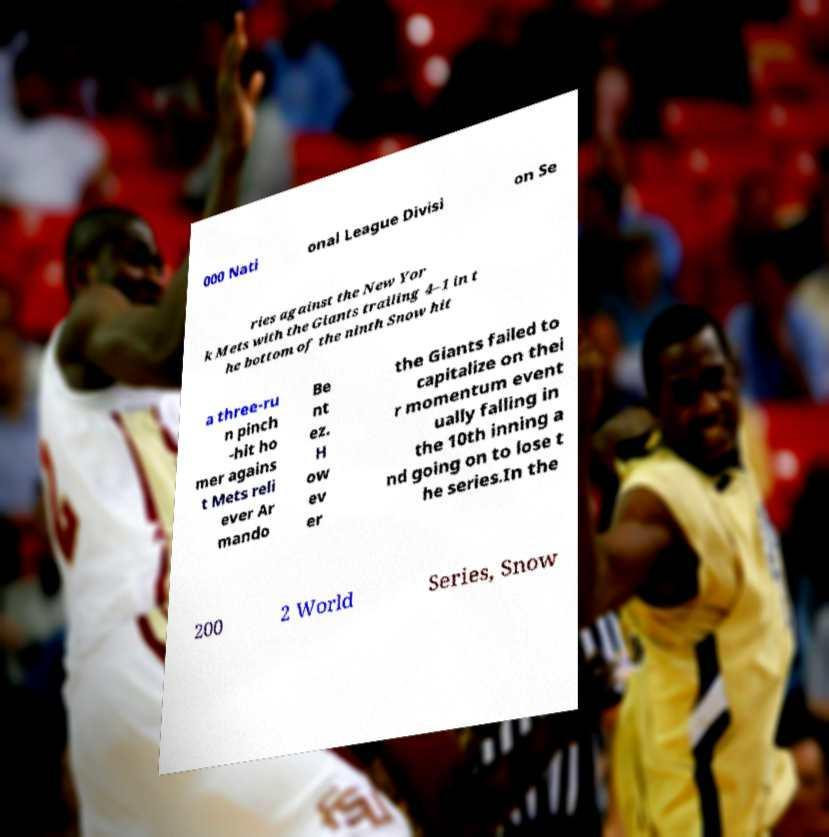There's text embedded in this image that I need extracted. Can you transcribe it verbatim? 000 Nati onal League Divisi on Se ries against the New Yor k Mets with the Giants trailing 4–1 in t he bottom of the ninth Snow hit a three-ru n pinch -hit ho mer agains t Mets reli ever Ar mando Be nt ez. H ow ev er the Giants failed to capitalize on thei r momentum event ually falling in the 10th inning a nd going on to lose t he series.In the 200 2 World Series, Snow 